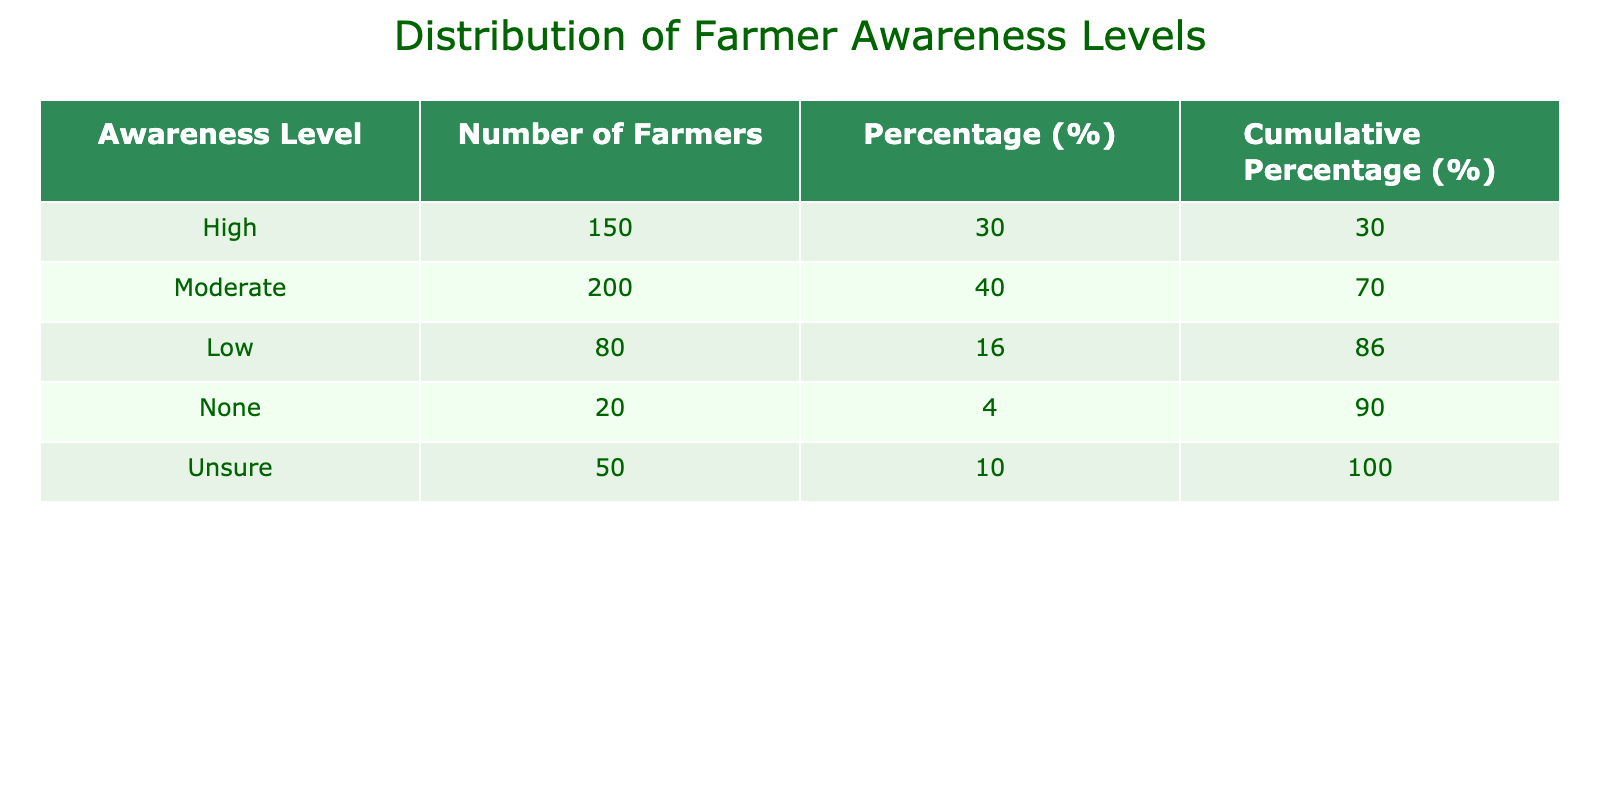What is the total number of farmers surveyed? To find the total number of farmers surveyed, we sum the values in the "Number of Farmers" column: 150 + 200 + 80 + 20 + 50 = 500.
Answer: 500 What percentage of farmers have a "High" awareness level? The percentage of farmers with a "High" awareness level is calculated as (Number of Farmers with High awareness / Total Number of Farmers) * 100. Here, it's (150 / 500) * 100 = 30.00%.
Answer: 30.00% Is the number of farmers with "Moderate" awareness greater than the number of those with "Low" awareness? To compare, we look at the values: "Moderate" has 200 farmers and "Low" has 80 farmers. Since 200 > 80, the answer is yes.
Answer: Yes What is the cumulative percentage of farmers with "Low" and "None" awareness levels combined? The cumulative percentage for "Low" is 34.00% (from Low's column) and for "None" is 38.00%. By summing these: 34.00% + 4.00% = 38.00%.
Answer: 4.00% How many farmers are either "Unsure" or have "No" awareness? To find this, we look at the numbers in "Unsure" (50 farmers) and "None" (20 farmers) and add them: 50 + 20 = 70.
Answer: 70 What is the difference in the number of farmers between the "High" and "None" awareness levels? The number of farmers with "High" awareness is 150 and with "None" is 20. The difference is calculated as 150 - 20 = 130.
Answer: 130 What proportion of farmers have at least "Moderate" awareness? "Moderate" awareness includes 200 farmers, "High" includes 150 farmers, so the total with at least "Moderate" awareness is 200 + 150 = 350. The proportion is calculated as (350 / 500) * 100 = 70%.
Answer: 70% What is the highest awareness level recorded in the table? By inspecting the "Awareness Level" column, "High" is the highest category listed.
Answer: High 